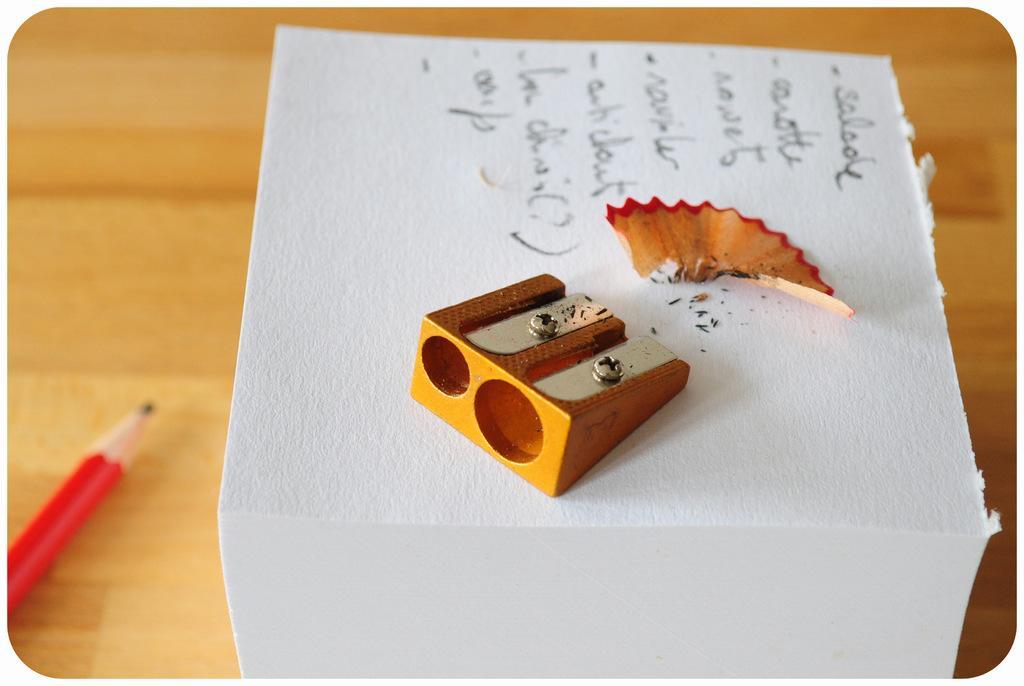Please provide a concise description of this image. Here in this picture we can see a table, on which we can see a pencil present and we can also see a chart with something written on it over there and on that we can see a sharper and the sharped pencil stuff present over there. 